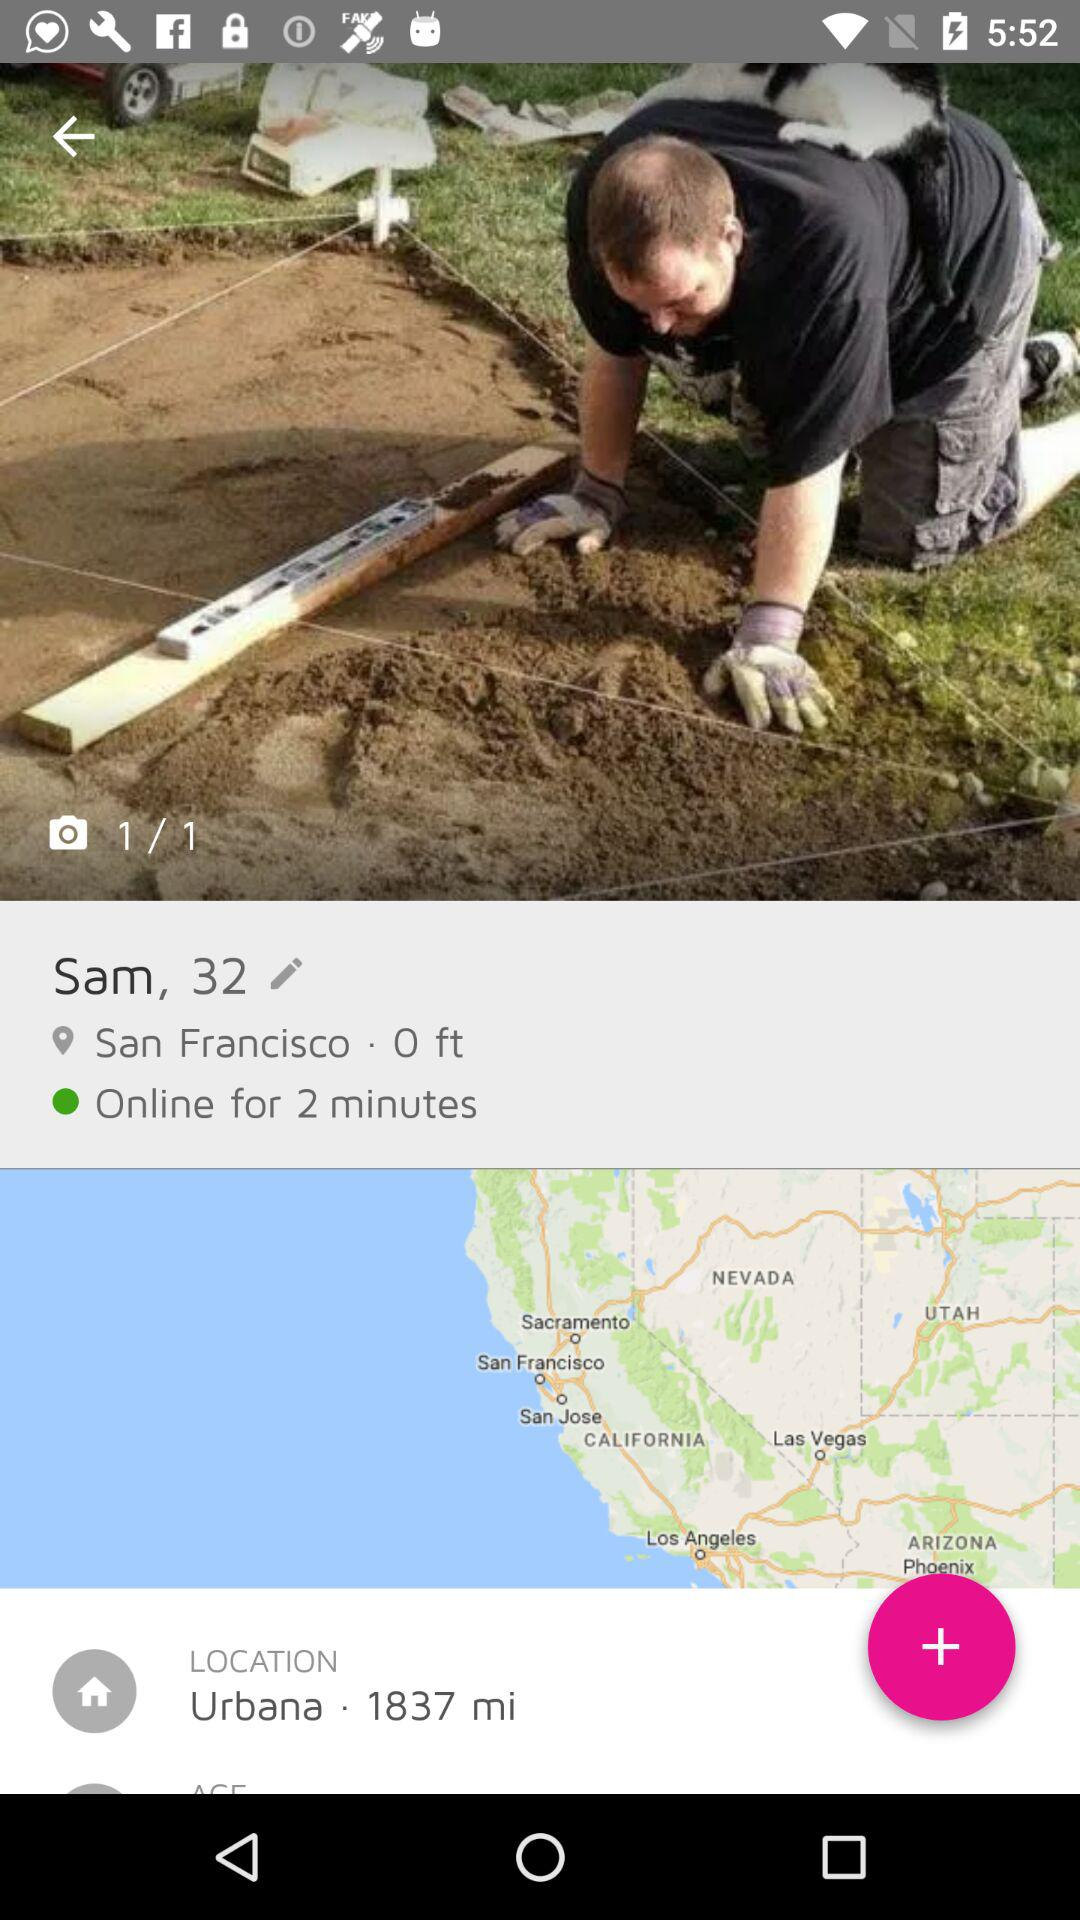What is the user name? The user name is Sam. 